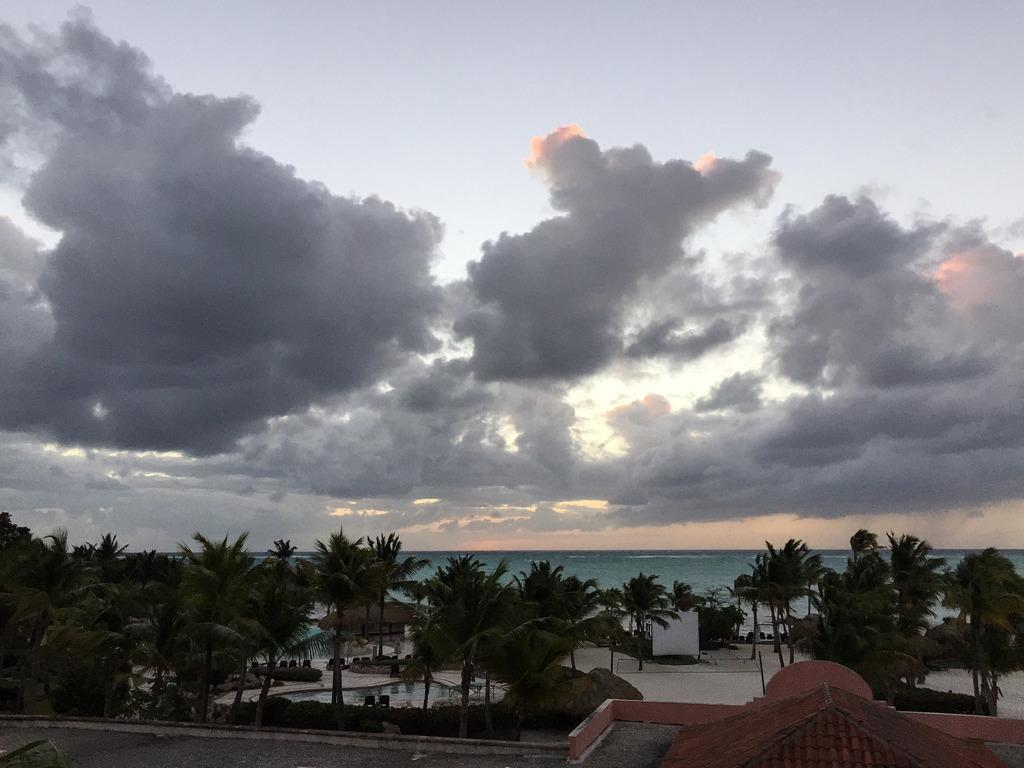What type of vegetation can be seen in the image? There are trees in the image. What recreational feature is present in the image? There is a swimming pool in the image. What type of seating is available in the image? There are chairs in the image. What architectural element is present in the image? There is a wall in the image. What type of storage structures can be seen in the image? There are sheds in the image. What type of living organisms can be seen in the image? There are plants in the image. What other objects can be seen in the image? There are other objects in the image, but their specific details are not mentioned in the facts. What can be seen in the background of the image? Water and sky are visible in the background of the image. What atmospheric feature can be seen in the sky? There are clouds in the sky. How many women are present in the image, and what is their approval rating? There is no mention of women or approval ratings in the image or the provided facts. 